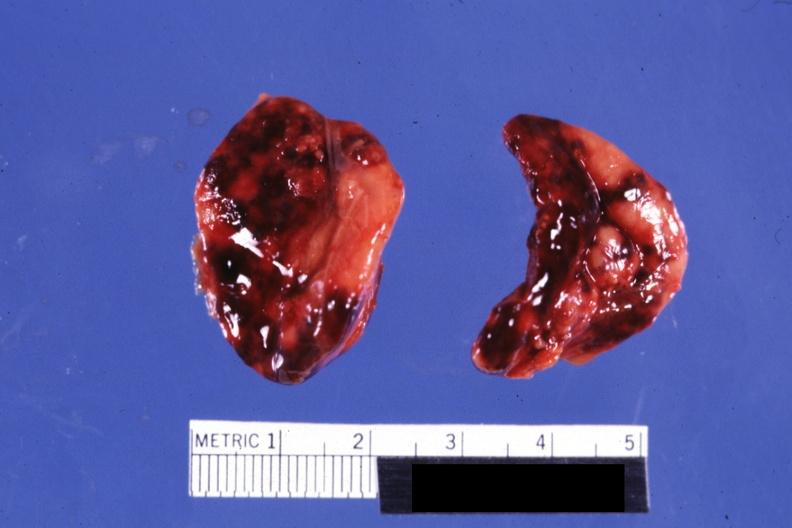what do not know history?
Answer the question using a single word or phrase. Focal hemorrhages 